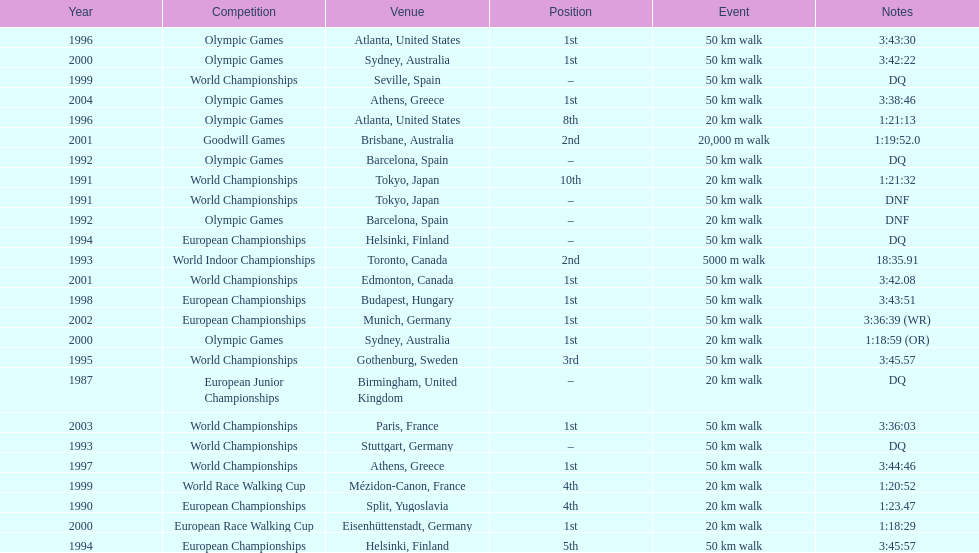How long did it take to walk 50 km in the 2004 olympic games? 3:38:46. 